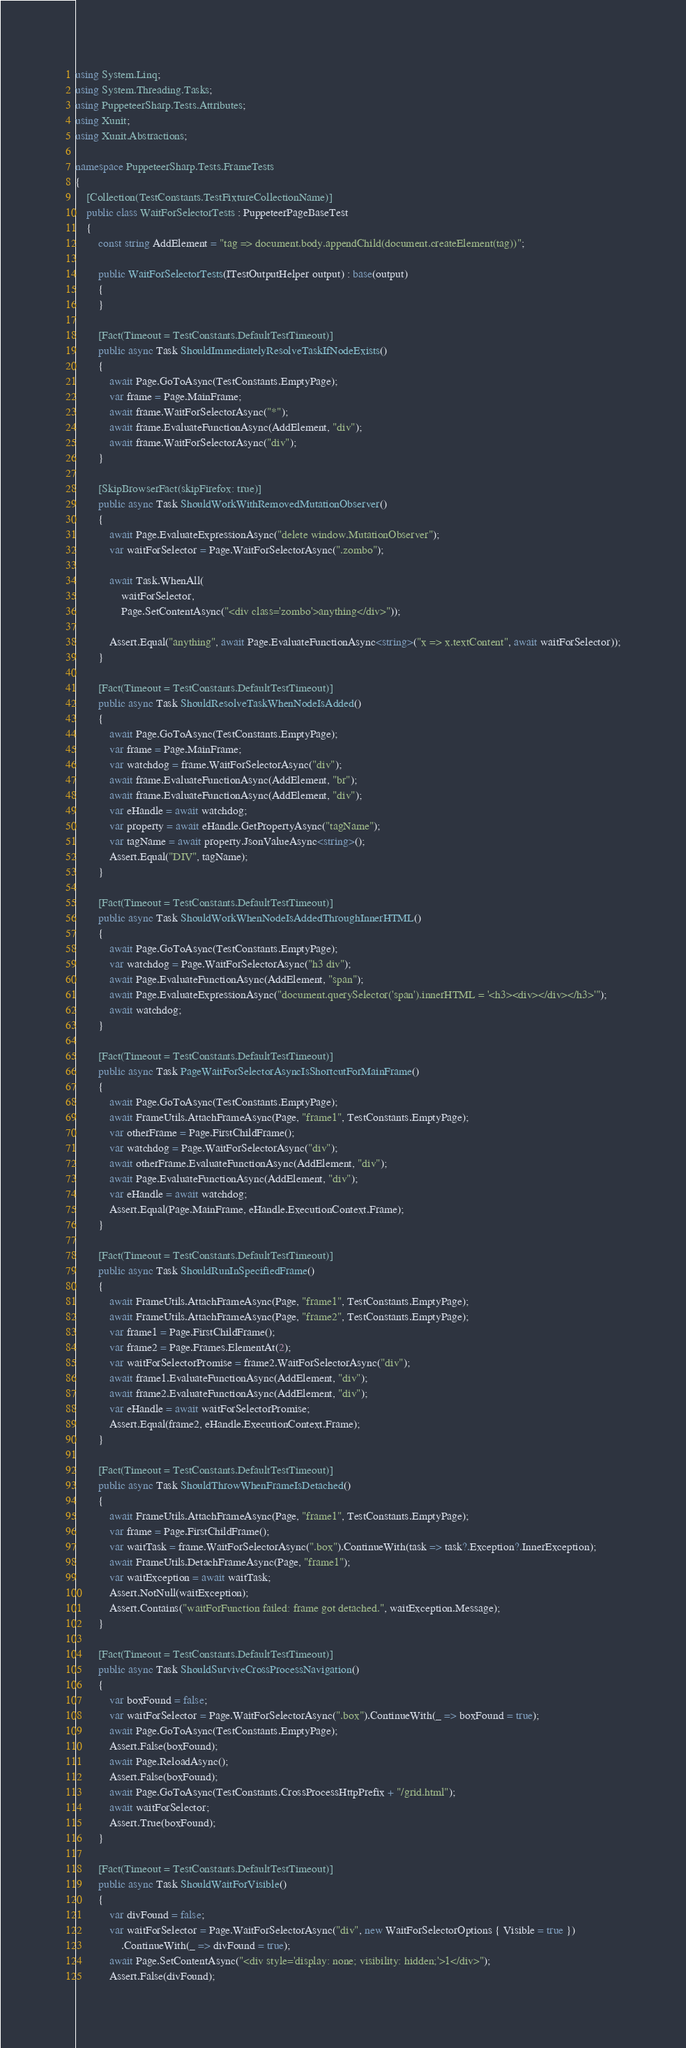<code> <loc_0><loc_0><loc_500><loc_500><_C#_>using System.Linq;
using System.Threading.Tasks;
using PuppeteerSharp.Tests.Attributes;
using Xunit;
using Xunit.Abstractions;

namespace PuppeteerSharp.Tests.FrameTests
{
    [Collection(TestConstants.TestFixtureCollectionName)]
    public class WaitForSelectorTests : PuppeteerPageBaseTest
    {
        const string AddElement = "tag => document.body.appendChild(document.createElement(tag))";

        public WaitForSelectorTests(ITestOutputHelper output) : base(output)
        {
        }

        [Fact(Timeout = TestConstants.DefaultTestTimeout)]
        public async Task ShouldImmediatelyResolveTaskIfNodeExists()
        {
            await Page.GoToAsync(TestConstants.EmptyPage);
            var frame = Page.MainFrame;
            await frame.WaitForSelectorAsync("*");
            await frame.EvaluateFunctionAsync(AddElement, "div");
            await frame.WaitForSelectorAsync("div");
        }

        [SkipBrowserFact(skipFirefox: true)]
        public async Task ShouldWorkWithRemovedMutationObserver()
        {
            await Page.EvaluateExpressionAsync("delete window.MutationObserver");
            var waitForSelector = Page.WaitForSelectorAsync(".zombo");

            await Task.WhenAll(
                waitForSelector,
                Page.SetContentAsync("<div class='zombo'>anything</div>"));

            Assert.Equal("anything", await Page.EvaluateFunctionAsync<string>("x => x.textContent", await waitForSelector));
        }

        [Fact(Timeout = TestConstants.DefaultTestTimeout)]
        public async Task ShouldResolveTaskWhenNodeIsAdded()
        {
            await Page.GoToAsync(TestConstants.EmptyPage);
            var frame = Page.MainFrame;
            var watchdog = frame.WaitForSelectorAsync("div");
            await frame.EvaluateFunctionAsync(AddElement, "br");
            await frame.EvaluateFunctionAsync(AddElement, "div");
            var eHandle = await watchdog;
            var property = await eHandle.GetPropertyAsync("tagName");
            var tagName = await property.JsonValueAsync<string>();
            Assert.Equal("DIV", tagName);
        }

        [Fact(Timeout = TestConstants.DefaultTestTimeout)]
        public async Task ShouldWorkWhenNodeIsAddedThroughInnerHTML()
        {
            await Page.GoToAsync(TestConstants.EmptyPage);
            var watchdog = Page.WaitForSelectorAsync("h3 div");
            await Page.EvaluateFunctionAsync(AddElement, "span");
            await Page.EvaluateExpressionAsync("document.querySelector('span').innerHTML = '<h3><div></div></h3>'");
            await watchdog;
        }

        [Fact(Timeout = TestConstants.DefaultTestTimeout)]
        public async Task PageWaitForSelectorAsyncIsShortcutForMainFrame()
        {
            await Page.GoToAsync(TestConstants.EmptyPage);
            await FrameUtils.AttachFrameAsync(Page, "frame1", TestConstants.EmptyPage);
            var otherFrame = Page.FirstChildFrame();
            var watchdog = Page.WaitForSelectorAsync("div");
            await otherFrame.EvaluateFunctionAsync(AddElement, "div");
            await Page.EvaluateFunctionAsync(AddElement, "div");
            var eHandle = await watchdog;
            Assert.Equal(Page.MainFrame, eHandle.ExecutionContext.Frame);
        }

        [Fact(Timeout = TestConstants.DefaultTestTimeout)]
        public async Task ShouldRunInSpecifiedFrame()
        {
            await FrameUtils.AttachFrameAsync(Page, "frame1", TestConstants.EmptyPage);
            await FrameUtils.AttachFrameAsync(Page, "frame2", TestConstants.EmptyPage);
            var frame1 = Page.FirstChildFrame();
            var frame2 = Page.Frames.ElementAt(2);
            var waitForSelectorPromise = frame2.WaitForSelectorAsync("div");
            await frame1.EvaluateFunctionAsync(AddElement, "div");
            await frame2.EvaluateFunctionAsync(AddElement, "div");
            var eHandle = await waitForSelectorPromise;
            Assert.Equal(frame2, eHandle.ExecutionContext.Frame);
        }

        [Fact(Timeout = TestConstants.DefaultTestTimeout)]
        public async Task ShouldThrowWhenFrameIsDetached()
        {
            await FrameUtils.AttachFrameAsync(Page, "frame1", TestConstants.EmptyPage);
            var frame = Page.FirstChildFrame();
            var waitTask = frame.WaitForSelectorAsync(".box").ContinueWith(task => task?.Exception?.InnerException);
            await FrameUtils.DetachFrameAsync(Page, "frame1");
            var waitException = await waitTask;
            Assert.NotNull(waitException);
            Assert.Contains("waitForFunction failed: frame got detached.", waitException.Message);
        }

        [Fact(Timeout = TestConstants.DefaultTestTimeout)]
        public async Task ShouldSurviveCrossProcessNavigation()
        {
            var boxFound = false;
            var waitForSelector = Page.WaitForSelectorAsync(".box").ContinueWith(_ => boxFound = true);
            await Page.GoToAsync(TestConstants.EmptyPage);
            Assert.False(boxFound);
            await Page.ReloadAsync();
            Assert.False(boxFound);
            await Page.GoToAsync(TestConstants.CrossProcessHttpPrefix + "/grid.html");
            await waitForSelector;
            Assert.True(boxFound);
        }

        [Fact(Timeout = TestConstants.DefaultTestTimeout)]
        public async Task ShouldWaitForVisible()
        {
            var divFound = false;
            var waitForSelector = Page.WaitForSelectorAsync("div", new WaitForSelectorOptions { Visible = true })
                .ContinueWith(_ => divFound = true);
            await Page.SetContentAsync("<div style='display: none; visibility: hidden;'>1</div>");
            Assert.False(divFound);</code> 